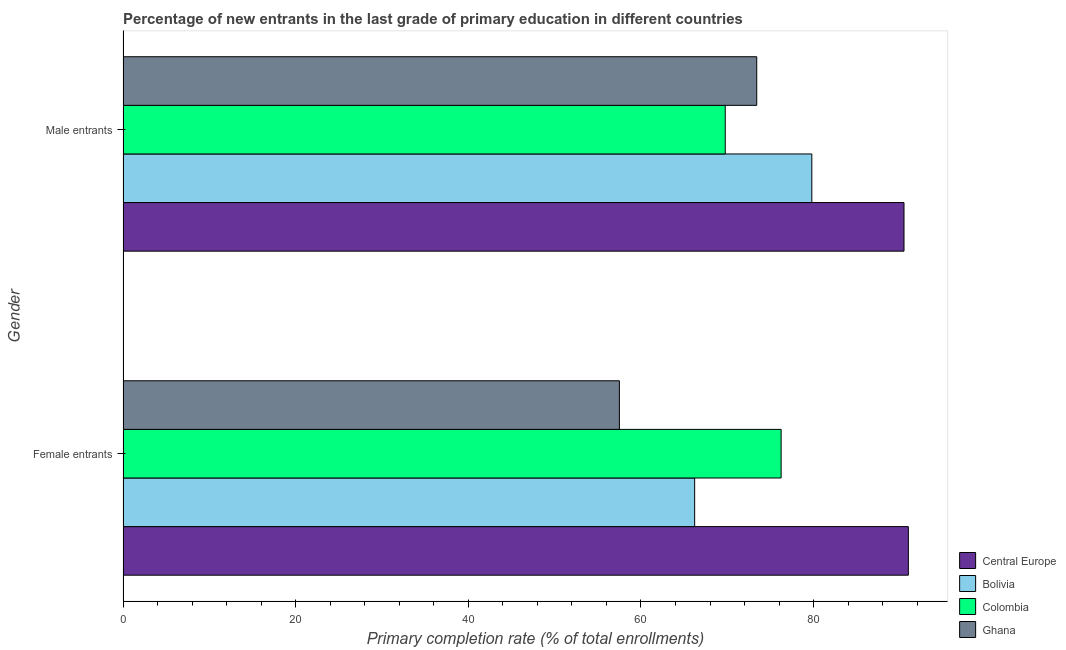How many groups of bars are there?
Keep it short and to the point. 2. Are the number of bars per tick equal to the number of legend labels?
Provide a succinct answer. Yes. What is the label of the 2nd group of bars from the top?
Your answer should be compact. Female entrants. What is the primary completion rate of male entrants in Ghana?
Offer a very short reply. 73.41. Across all countries, what is the maximum primary completion rate of female entrants?
Ensure brevity in your answer.  90.98. Across all countries, what is the minimum primary completion rate of male entrants?
Your response must be concise. 69.77. In which country was the primary completion rate of female entrants maximum?
Offer a terse response. Central Europe. In which country was the primary completion rate of male entrants minimum?
Ensure brevity in your answer.  Colombia. What is the total primary completion rate of female entrants in the graph?
Your answer should be very brief. 290.94. What is the difference between the primary completion rate of female entrants in Ghana and that in Colombia?
Your response must be concise. -18.74. What is the difference between the primary completion rate of female entrants in Bolivia and the primary completion rate of male entrants in Ghana?
Offer a terse response. -7.19. What is the average primary completion rate of female entrants per country?
Make the answer very short. 72.74. What is the difference between the primary completion rate of male entrants and primary completion rate of female entrants in Bolivia?
Give a very brief answer. 13.57. In how many countries, is the primary completion rate of female entrants greater than 44 %?
Provide a succinct answer. 4. What is the ratio of the primary completion rate of female entrants in Ghana to that in Colombia?
Provide a short and direct response. 0.75. Is the primary completion rate of female entrants in Ghana less than that in Bolivia?
Your answer should be very brief. Yes. What does the 3rd bar from the bottom in Male entrants represents?
Offer a terse response. Colombia. Are all the bars in the graph horizontal?
Make the answer very short. Yes. Are the values on the major ticks of X-axis written in scientific E-notation?
Your response must be concise. No. Does the graph contain any zero values?
Your response must be concise. No. Where does the legend appear in the graph?
Your response must be concise. Bottom right. How many legend labels are there?
Your answer should be very brief. 4. What is the title of the graph?
Your response must be concise. Percentage of new entrants in the last grade of primary education in different countries. Does "European Union" appear as one of the legend labels in the graph?
Offer a terse response. No. What is the label or title of the X-axis?
Your response must be concise. Primary completion rate (% of total enrollments). What is the Primary completion rate (% of total enrollments) in Central Europe in Female entrants?
Your answer should be compact. 90.98. What is the Primary completion rate (% of total enrollments) in Bolivia in Female entrants?
Keep it short and to the point. 66.22. What is the Primary completion rate (% of total enrollments) in Colombia in Female entrants?
Your answer should be compact. 76.24. What is the Primary completion rate (% of total enrollments) of Ghana in Female entrants?
Provide a short and direct response. 57.5. What is the Primary completion rate (% of total enrollments) of Central Europe in Male entrants?
Your answer should be compact. 90.47. What is the Primary completion rate (% of total enrollments) in Bolivia in Male entrants?
Give a very brief answer. 79.79. What is the Primary completion rate (% of total enrollments) in Colombia in Male entrants?
Your answer should be compact. 69.77. What is the Primary completion rate (% of total enrollments) of Ghana in Male entrants?
Offer a terse response. 73.41. Across all Gender, what is the maximum Primary completion rate (% of total enrollments) of Central Europe?
Offer a terse response. 90.98. Across all Gender, what is the maximum Primary completion rate (% of total enrollments) in Bolivia?
Keep it short and to the point. 79.79. Across all Gender, what is the maximum Primary completion rate (% of total enrollments) of Colombia?
Provide a short and direct response. 76.24. Across all Gender, what is the maximum Primary completion rate (% of total enrollments) in Ghana?
Offer a terse response. 73.41. Across all Gender, what is the minimum Primary completion rate (% of total enrollments) in Central Europe?
Ensure brevity in your answer.  90.47. Across all Gender, what is the minimum Primary completion rate (% of total enrollments) of Bolivia?
Ensure brevity in your answer.  66.22. Across all Gender, what is the minimum Primary completion rate (% of total enrollments) of Colombia?
Keep it short and to the point. 69.77. Across all Gender, what is the minimum Primary completion rate (% of total enrollments) in Ghana?
Your response must be concise. 57.5. What is the total Primary completion rate (% of total enrollments) of Central Europe in the graph?
Keep it short and to the point. 181.45. What is the total Primary completion rate (% of total enrollments) in Bolivia in the graph?
Ensure brevity in your answer.  146.02. What is the total Primary completion rate (% of total enrollments) of Colombia in the graph?
Keep it short and to the point. 146.01. What is the total Primary completion rate (% of total enrollments) of Ghana in the graph?
Your answer should be very brief. 130.92. What is the difference between the Primary completion rate (% of total enrollments) of Central Europe in Female entrants and that in Male entrants?
Provide a short and direct response. 0.5. What is the difference between the Primary completion rate (% of total enrollments) of Bolivia in Female entrants and that in Male entrants?
Your answer should be compact. -13.57. What is the difference between the Primary completion rate (% of total enrollments) of Colombia in Female entrants and that in Male entrants?
Give a very brief answer. 6.47. What is the difference between the Primary completion rate (% of total enrollments) of Ghana in Female entrants and that in Male entrants?
Make the answer very short. -15.91. What is the difference between the Primary completion rate (% of total enrollments) of Central Europe in Female entrants and the Primary completion rate (% of total enrollments) of Bolivia in Male entrants?
Give a very brief answer. 11.18. What is the difference between the Primary completion rate (% of total enrollments) in Central Europe in Female entrants and the Primary completion rate (% of total enrollments) in Colombia in Male entrants?
Offer a very short reply. 21.21. What is the difference between the Primary completion rate (% of total enrollments) of Central Europe in Female entrants and the Primary completion rate (% of total enrollments) of Ghana in Male entrants?
Give a very brief answer. 17.56. What is the difference between the Primary completion rate (% of total enrollments) of Bolivia in Female entrants and the Primary completion rate (% of total enrollments) of Colombia in Male entrants?
Offer a terse response. -3.54. What is the difference between the Primary completion rate (% of total enrollments) of Bolivia in Female entrants and the Primary completion rate (% of total enrollments) of Ghana in Male entrants?
Keep it short and to the point. -7.19. What is the difference between the Primary completion rate (% of total enrollments) in Colombia in Female entrants and the Primary completion rate (% of total enrollments) in Ghana in Male entrants?
Keep it short and to the point. 2.83. What is the average Primary completion rate (% of total enrollments) of Central Europe per Gender?
Your response must be concise. 90.73. What is the average Primary completion rate (% of total enrollments) of Bolivia per Gender?
Ensure brevity in your answer.  73.01. What is the average Primary completion rate (% of total enrollments) of Colombia per Gender?
Provide a succinct answer. 73. What is the average Primary completion rate (% of total enrollments) of Ghana per Gender?
Give a very brief answer. 65.46. What is the difference between the Primary completion rate (% of total enrollments) of Central Europe and Primary completion rate (% of total enrollments) of Bolivia in Female entrants?
Your answer should be compact. 24.75. What is the difference between the Primary completion rate (% of total enrollments) of Central Europe and Primary completion rate (% of total enrollments) of Colombia in Female entrants?
Your answer should be compact. 14.74. What is the difference between the Primary completion rate (% of total enrollments) in Central Europe and Primary completion rate (% of total enrollments) in Ghana in Female entrants?
Your answer should be very brief. 33.47. What is the difference between the Primary completion rate (% of total enrollments) of Bolivia and Primary completion rate (% of total enrollments) of Colombia in Female entrants?
Your response must be concise. -10.02. What is the difference between the Primary completion rate (% of total enrollments) of Bolivia and Primary completion rate (% of total enrollments) of Ghana in Female entrants?
Keep it short and to the point. 8.72. What is the difference between the Primary completion rate (% of total enrollments) of Colombia and Primary completion rate (% of total enrollments) of Ghana in Female entrants?
Offer a terse response. 18.74. What is the difference between the Primary completion rate (% of total enrollments) in Central Europe and Primary completion rate (% of total enrollments) in Bolivia in Male entrants?
Your response must be concise. 10.68. What is the difference between the Primary completion rate (% of total enrollments) in Central Europe and Primary completion rate (% of total enrollments) in Colombia in Male entrants?
Give a very brief answer. 20.71. What is the difference between the Primary completion rate (% of total enrollments) in Central Europe and Primary completion rate (% of total enrollments) in Ghana in Male entrants?
Keep it short and to the point. 17.06. What is the difference between the Primary completion rate (% of total enrollments) in Bolivia and Primary completion rate (% of total enrollments) in Colombia in Male entrants?
Keep it short and to the point. 10.03. What is the difference between the Primary completion rate (% of total enrollments) in Bolivia and Primary completion rate (% of total enrollments) in Ghana in Male entrants?
Offer a terse response. 6.38. What is the difference between the Primary completion rate (% of total enrollments) of Colombia and Primary completion rate (% of total enrollments) of Ghana in Male entrants?
Offer a terse response. -3.65. What is the ratio of the Primary completion rate (% of total enrollments) of Central Europe in Female entrants to that in Male entrants?
Keep it short and to the point. 1.01. What is the ratio of the Primary completion rate (% of total enrollments) in Bolivia in Female entrants to that in Male entrants?
Provide a succinct answer. 0.83. What is the ratio of the Primary completion rate (% of total enrollments) in Colombia in Female entrants to that in Male entrants?
Provide a succinct answer. 1.09. What is the ratio of the Primary completion rate (% of total enrollments) in Ghana in Female entrants to that in Male entrants?
Your response must be concise. 0.78. What is the difference between the highest and the second highest Primary completion rate (% of total enrollments) in Central Europe?
Keep it short and to the point. 0.5. What is the difference between the highest and the second highest Primary completion rate (% of total enrollments) of Bolivia?
Provide a short and direct response. 13.57. What is the difference between the highest and the second highest Primary completion rate (% of total enrollments) in Colombia?
Your response must be concise. 6.47. What is the difference between the highest and the second highest Primary completion rate (% of total enrollments) of Ghana?
Make the answer very short. 15.91. What is the difference between the highest and the lowest Primary completion rate (% of total enrollments) of Central Europe?
Your answer should be very brief. 0.5. What is the difference between the highest and the lowest Primary completion rate (% of total enrollments) of Bolivia?
Make the answer very short. 13.57. What is the difference between the highest and the lowest Primary completion rate (% of total enrollments) in Colombia?
Give a very brief answer. 6.47. What is the difference between the highest and the lowest Primary completion rate (% of total enrollments) of Ghana?
Provide a succinct answer. 15.91. 